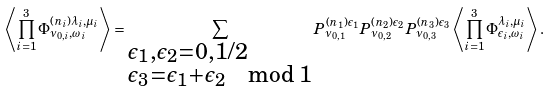<formula> <loc_0><loc_0><loc_500><loc_500>\left \langle \prod _ { i = 1 } ^ { 3 } \Phi ^ { ( n _ { i } ) \lambda _ { i } , \mu _ { i } } _ { \nu _ { 0 , i } , \omega _ { i } } \right \rangle = \sum _ { \begin{subarray} { c } \epsilon _ { 1 } , \epsilon _ { 2 } = 0 , 1 / 2 \\ \epsilon _ { 3 } = \epsilon _ { 1 } + \epsilon _ { 2 } \mod 1 \end{subarray} } P ^ { ( n _ { 1 } ) \epsilon _ { 1 } } _ { \nu _ { 0 , 1 } } P ^ { ( n _ { 2 } ) \epsilon _ { 2 } } _ { \nu _ { 0 , 2 } } P ^ { ( n _ { 3 } ) \epsilon _ { 3 } } _ { \nu _ { 0 , 3 } } \left \langle \prod _ { i = 1 } ^ { 3 } \Phi ^ { \lambda _ { i } , \mu _ { i } } _ { \epsilon _ { i } , \omega _ { i } } \right \rangle .</formula> 